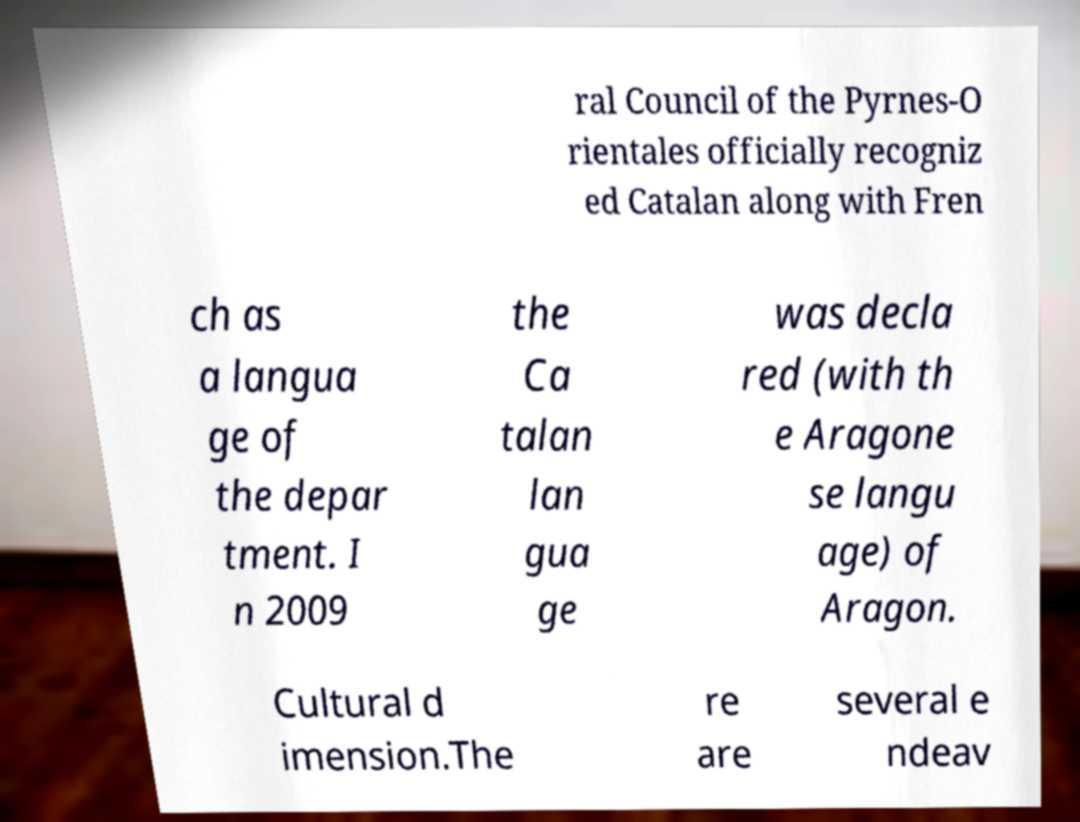For documentation purposes, I need the text within this image transcribed. Could you provide that? ral Council of the Pyrnes-O rientales officially recogniz ed Catalan along with Fren ch as a langua ge of the depar tment. I n 2009 the Ca talan lan gua ge was decla red (with th e Aragone se langu age) of Aragon. Cultural d imension.The re are several e ndeav 